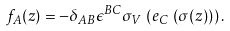<formula> <loc_0><loc_0><loc_500><loc_500>f _ { A } ( z ) = - \delta _ { A B } \epsilon ^ { B C } \sigma _ { V } \, \left ( e _ { C } \, \left ( \sigma ( z ) \right ) \right ) .</formula> 